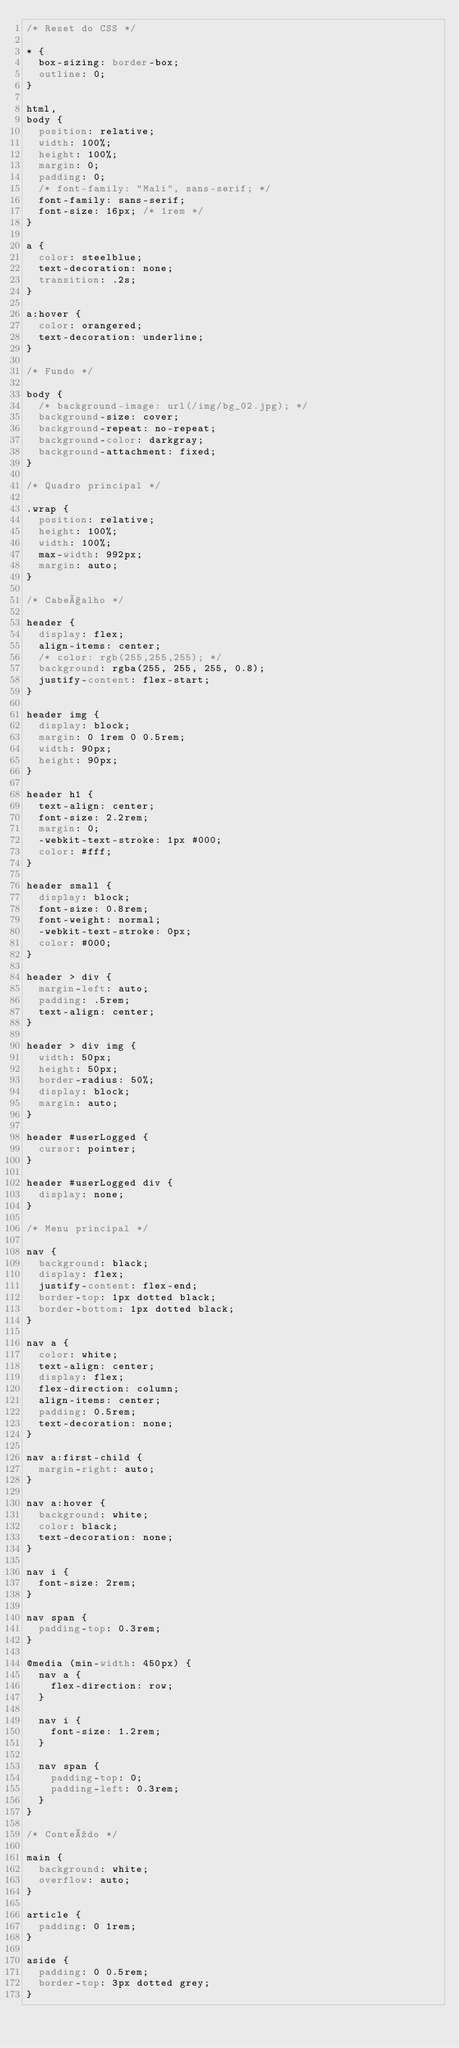Convert code to text. <code><loc_0><loc_0><loc_500><loc_500><_CSS_>/* Reset do CSS */

* {
  box-sizing: border-box;
  outline: 0;
}

html,
body {
  position: relative;
  width: 100%;
  height: 100%;
  margin: 0;
  padding: 0;
  /* font-family: "Mali", sans-serif; */
  font-family: sans-serif;
  font-size: 16px; /* 1rem */
}

a {
  color: steelblue;
  text-decoration: none;
  transition: .2s;
}

a:hover {
  color: orangered;
  text-decoration: underline;
}

/* Fundo */

body {
  /* background-image: url(/img/bg_02.jpg); */
  background-size: cover;
  background-repeat: no-repeat;
  background-color: darkgray;
  background-attachment: fixed;
}

/* Quadro principal */

.wrap {
  position: relative;
  height: 100%;
  width: 100%;
  max-width: 992px;
  margin: auto;
}

/* Cabeçalho */

header {
  display: flex;
  align-items: center;
  /* color: rgb(255,255,255); */
  background: rgba(255, 255, 255, 0.8);
  justify-content: flex-start;
}

header img {
  display: block;
  margin: 0 1rem 0 0.5rem;
  width: 90px;
  height: 90px;
}

header h1 {
  text-align: center;
  font-size: 2.2rem;
  margin: 0;
  -webkit-text-stroke: 1px #000;
  color: #fff;
}

header small {
  display: block;
  font-size: 0.8rem;
  font-weight: normal;
  -webkit-text-stroke: 0px;
  color: #000;
}

header > div {
  margin-left: auto;
  padding: .5rem;
  text-align: center;
}

header > div img {
  width: 50px;
  height: 50px;
  border-radius: 50%;
  display: block;
  margin: auto;
}

header #userLogged {
  cursor: pointer;
}

header #userLogged div {
  display: none;
}

/* Menu principal */

nav {
  background: black;
  display: flex;
  justify-content: flex-end;
  border-top: 1px dotted black;
  border-bottom: 1px dotted black;
}

nav a {
  color: white;
  text-align: center;
  display: flex;
  flex-direction: column;
  align-items: center;
  padding: 0.5rem;
  text-decoration: none;
}

nav a:first-child {
  margin-right: auto;
}

nav a:hover {
  background: white;
  color: black;
  text-decoration: none;
}

nav i {
  font-size: 2rem;
}

nav span {
  padding-top: 0.3rem;
}

@media (min-width: 450px) {
  nav a {
    flex-direction: row;
  }

  nav i {
    font-size: 1.2rem;
  }

  nav span {
    padding-top: 0;
    padding-left: 0.3rem;
  }
}

/* Conteúdo */

main {
  background: white;
  overflow: auto;
}

article {
  padding: 0 1rem;
}

aside {
  padding: 0 0.5rem;
  border-top: 3px dotted grey;
}
</code> 